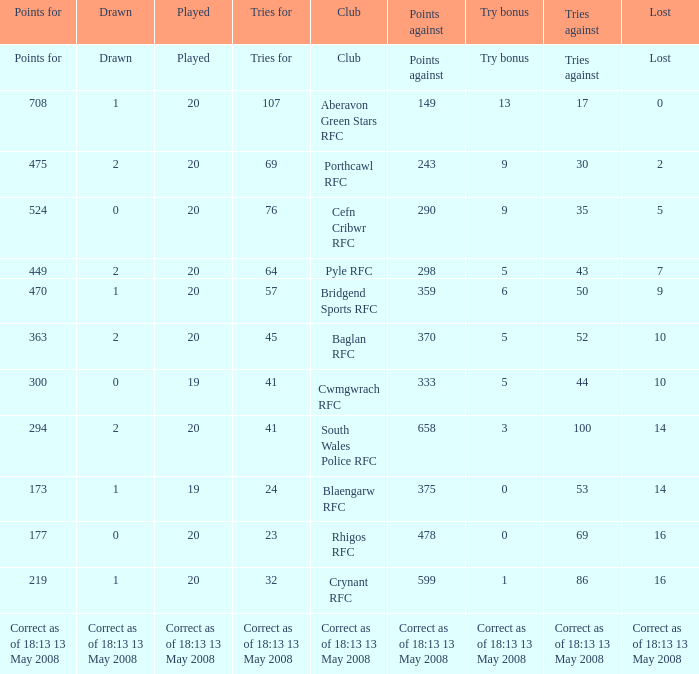What is the tries against when the points are 475? 30.0. Parse the table in full. {'header': ['Points for', 'Drawn', 'Played', 'Tries for', 'Club', 'Points against', 'Try bonus', 'Tries against', 'Lost'], 'rows': [['Points for', 'Drawn', 'Played', 'Tries for', 'Club', 'Points against', 'Try bonus', 'Tries against', 'Lost'], ['708', '1', '20', '107', 'Aberavon Green Stars RFC', '149', '13', '17', '0'], ['475', '2', '20', '69', 'Porthcawl RFC', '243', '9', '30', '2'], ['524', '0', '20', '76', 'Cefn Cribwr RFC', '290', '9', '35', '5'], ['449', '2', '20', '64', 'Pyle RFC', '298', '5', '43', '7'], ['470', '1', '20', '57', 'Bridgend Sports RFC', '359', '6', '50', '9'], ['363', '2', '20', '45', 'Baglan RFC', '370', '5', '52', '10'], ['300', '0', '19', '41', 'Cwmgwrach RFC', '333', '5', '44', '10'], ['294', '2', '20', '41', 'South Wales Police RFC', '658', '3', '100', '14'], ['173', '1', '19', '24', 'Blaengarw RFC', '375', '0', '53', '14'], ['177', '0', '20', '23', 'Rhigos RFC', '478', '0', '69', '16'], ['219', '1', '20', '32', 'Crynant RFC', '599', '1', '86', '16'], ['Correct as of 18:13 13 May 2008', 'Correct as of 18:13 13 May 2008', 'Correct as of 18:13 13 May 2008', 'Correct as of 18:13 13 May 2008', 'Correct as of 18:13 13 May 2008', 'Correct as of 18:13 13 May 2008', 'Correct as of 18:13 13 May 2008', 'Correct as of 18:13 13 May 2008', 'Correct as of 18:13 13 May 2008']]} 